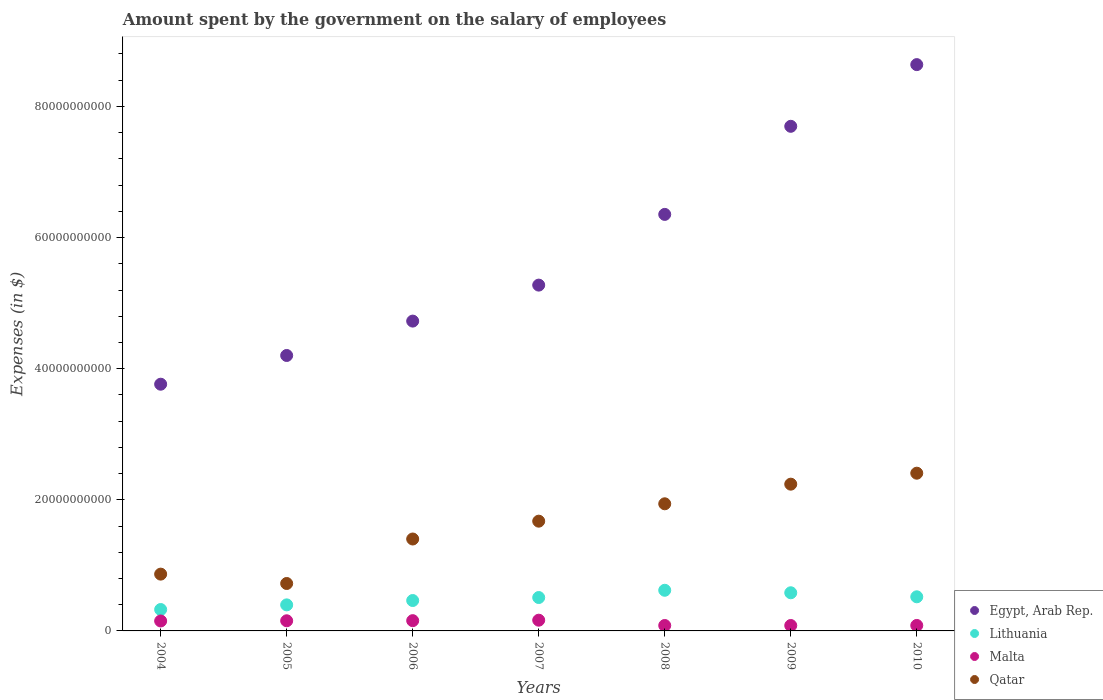How many different coloured dotlines are there?
Make the answer very short. 4. What is the amount spent on the salary of employees by the government in Qatar in 2008?
Your answer should be compact. 1.94e+1. Across all years, what is the maximum amount spent on the salary of employees by the government in Malta?
Your response must be concise. 1.64e+09. Across all years, what is the minimum amount spent on the salary of employees by the government in Malta?
Provide a short and direct response. 8.25e+08. In which year was the amount spent on the salary of employees by the government in Qatar minimum?
Keep it short and to the point. 2005. What is the total amount spent on the salary of employees by the government in Lithuania in the graph?
Keep it short and to the point. 3.42e+1. What is the difference between the amount spent on the salary of employees by the government in Malta in 2004 and that in 2006?
Your answer should be compact. -4.90e+07. What is the difference between the amount spent on the salary of employees by the government in Lithuania in 2009 and the amount spent on the salary of employees by the government in Qatar in 2010?
Make the answer very short. -1.82e+1. What is the average amount spent on the salary of employees by the government in Lithuania per year?
Your answer should be very brief. 4.88e+09. In the year 2006, what is the difference between the amount spent on the salary of employees by the government in Qatar and amount spent on the salary of employees by the government in Egypt, Arab Rep.?
Your answer should be very brief. -3.32e+1. In how many years, is the amount spent on the salary of employees by the government in Malta greater than 72000000000 $?
Ensure brevity in your answer.  0. What is the ratio of the amount spent on the salary of employees by the government in Malta in 2009 to that in 2010?
Make the answer very short. 0.99. Is the amount spent on the salary of employees by the government in Lithuania in 2004 less than that in 2008?
Keep it short and to the point. Yes. Is the difference between the amount spent on the salary of employees by the government in Qatar in 2008 and 2010 greater than the difference between the amount spent on the salary of employees by the government in Egypt, Arab Rep. in 2008 and 2010?
Your answer should be very brief. Yes. What is the difference between the highest and the second highest amount spent on the salary of employees by the government in Qatar?
Keep it short and to the point. 1.67e+09. What is the difference between the highest and the lowest amount spent on the salary of employees by the government in Egypt, Arab Rep.?
Offer a terse response. 4.87e+1. Is the sum of the amount spent on the salary of employees by the government in Lithuania in 2004 and 2006 greater than the maximum amount spent on the salary of employees by the government in Egypt, Arab Rep. across all years?
Give a very brief answer. No. Is it the case that in every year, the sum of the amount spent on the salary of employees by the government in Qatar and amount spent on the salary of employees by the government in Malta  is greater than the sum of amount spent on the salary of employees by the government in Egypt, Arab Rep. and amount spent on the salary of employees by the government in Lithuania?
Give a very brief answer. No. Is it the case that in every year, the sum of the amount spent on the salary of employees by the government in Qatar and amount spent on the salary of employees by the government in Lithuania  is greater than the amount spent on the salary of employees by the government in Malta?
Your answer should be very brief. Yes. Does the amount spent on the salary of employees by the government in Egypt, Arab Rep. monotonically increase over the years?
Provide a short and direct response. Yes. Does the graph contain grids?
Make the answer very short. No. How many legend labels are there?
Ensure brevity in your answer.  4. What is the title of the graph?
Your answer should be compact. Amount spent by the government on the salary of employees. What is the label or title of the Y-axis?
Provide a succinct answer. Expenses (in $). What is the Expenses (in $) in Egypt, Arab Rep. in 2004?
Provide a succinct answer. 3.76e+1. What is the Expenses (in $) in Lithuania in 2004?
Provide a short and direct response. 3.27e+09. What is the Expenses (in $) of Malta in 2004?
Your response must be concise. 1.52e+09. What is the Expenses (in $) in Qatar in 2004?
Offer a terse response. 8.66e+09. What is the Expenses (in $) of Egypt, Arab Rep. in 2005?
Your response must be concise. 4.20e+1. What is the Expenses (in $) in Lithuania in 2005?
Make the answer very short. 3.97e+09. What is the Expenses (in $) of Malta in 2005?
Offer a terse response. 1.55e+09. What is the Expenses (in $) in Qatar in 2005?
Make the answer very short. 7.23e+09. What is the Expenses (in $) in Egypt, Arab Rep. in 2006?
Provide a succinct answer. 4.73e+1. What is the Expenses (in $) in Lithuania in 2006?
Your answer should be very brief. 4.64e+09. What is the Expenses (in $) in Malta in 2006?
Your answer should be compact. 1.57e+09. What is the Expenses (in $) of Qatar in 2006?
Your answer should be compact. 1.40e+1. What is the Expenses (in $) in Egypt, Arab Rep. in 2007?
Provide a succinct answer. 5.27e+1. What is the Expenses (in $) in Lithuania in 2007?
Provide a succinct answer. 5.09e+09. What is the Expenses (in $) in Malta in 2007?
Ensure brevity in your answer.  1.64e+09. What is the Expenses (in $) in Qatar in 2007?
Make the answer very short. 1.67e+1. What is the Expenses (in $) in Egypt, Arab Rep. in 2008?
Provide a short and direct response. 6.35e+1. What is the Expenses (in $) of Lithuania in 2008?
Make the answer very short. 6.20e+09. What is the Expenses (in $) in Malta in 2008?
Provide a short and direct response. 8.27e+08. What is the Expenses (in $) of Qatar in 2008?
Your answer should be compact. 1.94e+1. What is the Expenses (in $) of Egypt, Arab Rep. in 2009?
Make the answer very short. 7.70e+1. What is the Expenses (in $) of Lithuania in 2009?
Make the answer very short. 5.82e+09. What is the Expenses (in $) in Malta in 2009?
Offer a terse response. 8.25e+08. What is the Expenses (in $) of Qatar in 2009?
Ensure brevity in your answer.  2.24e+1. What is the Expenses (in $) in Egypt, Arab Rep. in 2010?
Ensure brevity in your answer.  8.64e+1. What is the Expenses (in $) of Lithuania in 2010?
Give a very brief answer. 5.20e+09. What is the Expenses (in $) in Malta in 2010?
Ensure brevity in your answer.  8.35e+08. What is the Expenses (in $) in Qatar in 2010?
Your answer should be very brief. 2.41e+1. Across all years, what is the maximum Expenses (in $) in Egypt, Arab Rep.?
Provide a succinct answer. 8.64e+1. Across all years, what is the maximum Expenses (in $) of Lithuania?
Your answer should be very brief. 6.20e+09. Across all years, what is the maximum Expenses (in $) in Malta?
Make the answer very short. 1.64e+09. Across all years, what is the maximum Expenses (in $) in Qatar?
Provide a succinct answer. 2.41e+1. Across all years, what is the minimum Expenses (in $) of Egypt, Arab Rep.?
Your response must be concise. 3.76e+1. Across all years, what is the minimum Expenses (in $) of Lithuania?
Ensure brevity in your answer.  3.27e+09. Across all years, what is the minimum Expenses (in $) of Malta?
Keep it short and to the point. 8.25e+08. Across all years, what is the minimum Expenses (in $) in Qatar?
Give a very brief answer. 7.23e+09. What is the total Expenses (in $) in Egypt, Arab Rep. in the graph?
Ensure brevity in your answer.  4.07e+11. What is the total Expenses (in $) of Lithuania in the graph?
Provide a short and direct response. 3.42e+1. What is the total Expenses (in $) of Malta in the graph?
Your response must be concise. 8.75e+09. What is the total Expenses (in $) in Qatar in the graph?
Offer a very short reply. 1.12e+11. What is the difference between the Expenses (in $) in Egypt, Arab Rep. in 2004 and that in 2005?
Provide a succinct answer. -4.38e+09. What is the difference between the Expenses (in $) in Lithuania in 2004 and that in 2005?
Ensure brevity in your answer.  -7.08e+08. What is the difference between the Expenses (in $) in Malta in 2004 and that in 2005?
Offer a terse response. -3.07e+07. What is the difference between the Expenses (in $) in Qatar in 2004 and that in 2005?
Your answer should be compact. 1.43e+09. What is the difference between the Expenses (in $) of Egypt, Arab Rep. in 2004 and that in 2006?
Offer a very short reply. -9.63e+09. What is the difference between the Expenses (in $) in Lithuania in 2004 and that in 2006?
Make the answer very short. -1.37e+09. What is the difference between the Expenses (in $) in Malta in 2004 and that in 2006?
Ensure brevity in your answer.  -4.90e+07. What is the difference between the Expenses (in $) of Qatar in 2004 and that in 2006?
Make the answer very short. -5.36e+09. What is the difference between the Expenses (in $) of Egypt, Arab Rep. in 2004 and that in 2007?
Keep it short and to the point. -1.51e+1. What is the difference between the Expenses (in $) in Lithuania in 2004 and that in 2007?
Give a very brief answer. -1.83e+09. What is the difference between the Expenses (in $) in Malta in 2004 and that in 2007?
Give a very brief answer. -1.21e+08. What is the difference between the Expenses (in $) of Qatar in 2004 and that in 2007?
Offer a terse response. -8.08e+09. What is the difference between the Expenses (in $) of Egypt, Arab Rep. in 2004 and that in 2008?
Your answer should be compact. -2.59e+1. What is the difference between the Expenses (in $) of Lithuania in 2004 and that in 2008?
Your answer should be compact. -2.93e+09. What is the difference between the Expenses (in $) of Malta in 2004 and that in 2008?
Ensure brevity in your answer.  6.89e+08. What is the difference between the Expenses (in $) of Qatar in 2004 and that in 2008?
Offer a very short reply. -1.07e+1. What is the difference between the Expenses (in $) in Egypt, Arab Rep. in 2004 and that in 2009?
Offer a very short reply. -3.93e+1. What is the difference between the Expenses (in $) in Lithuania in 2004 and that in 2009?
Your answer should be very brief. -2.55e+09. What is the difference between the Expenses (in $) of Malta in 2004 and that in 2009?
Your answer should be very brief. 6.91e+08. What is the difference between the Expenses (in $) in Qatar in 2004 and that in 2009?
Give a very brief answer. -1.37e+1. What is the difference between the Expenses (in $) in Egypt, Arab Rep. in 2004 and that in 2010?
Your answer should be very brief. -4.87e+1. What is the difference between the Expenses (in $) of Lithuania in 2004 and that in 2010?
Provide a succinct answer. -1.94e+09. What is the difference between the Expenses (in $) of Malta in 2004 and that in 2010?
Ensure brevity in your answer.  6.81e+08. What is the difference between the Expenses (in $) in Qatar in 2004 and that in 2010?
Make the answer very short. -1.54e+1. What is the difference between the Expenses (in $) of Egypt, Arab Rep. in 2005 and that in 2006?
Your response must be concise. -5.25e+09. What is the difference between the Expenses (in $) in Lithuania in 2005 and that in 2006?
Offer a terse response. -6.63e+08. What is the difference between the Expenses (in $) in Malta in 2005 and that in 2006?
Give a very brief answer. -1.82e+07. What is the difference between the Expenses (in $) of Qatar in 2005 and that in 2006?
Make the answer very short. -6.79e+09. What is the difference between the Expenses (in $) of Egypt, Arab Rep. in 2005 and that in 2007?
Offer a very short reply. -1.07e+1. What is the difference between the Expenses (in $) of Lithuania in 2005 and that in 2007?
Provide a succinct answer. -1.12e+09. What is the difference between the Expenses (in $) of Malta in 2005 and that in 2007?
Offer a very short reply. -9.01e+07. What is the difference between the Expenses (in $) of Qatar in 2005 and that in 2007?
Ensure brevity in your answer.  -9.51e+09. What is the difference between the Expenses (in $) in Egypt, Arab Rep. in 2005 and that in 2008?
Provide a succinct answer. -2.15e+1. What is the difference between the Expenses (in $) in Lithuania in 2005 and that in 2008?
Make the answer very short. -2.23e+09. What is the difference between the Expenses (in $) in Malta in 2005 and that in 2008?
Your answer should be compact. 7.20e+08. What is the difference between the Expenses (in $) in Qatar in 2005 and that in 2008?
Provide a succinct answer. -1.22e+1. What is the difference between the Expenses (in $) of Egypt, Arab Rep. in 2005 and that in 2009?
Provide a short and direct response. -3.50e+1. What is the difference between the Expenses (in $) in Lithuania in 2005 and that in 2009?
Your answer should be compact. -1.85e+09. What is the difference between the Expenses (in $) of Malta in 2005 and that in 2009?
Offer a very short reply. 7.22e+08. What is the difference between the Expenses (in $) in Qatar in 2005 and that in 2009?
Make the answer very short. -1.52e+1. What is the difference between the Expenses (in $) of Egypt, Arab Rep. in 2005 and that in 2010?
Make the answer very short. -4.44e+1. What is the difference between the Expenses (in $) in Lithuania in 2005 and that in 2010?
Offer a terse response. -1.23e+09. What is the difference between the Expenses (in $) in Malta in 2005 and that in 2010?
Your answer should be compact. 7.12e+08. What is the difference between the Expenses (in $) in Qatar in 2005 and that in 2010?
Offer a terse response. -1.68e+1. What is the difference between the Expenses (in $) of Egypt, Arab Rep. in 2006 and that in 2007?
Provide a short and direct response. -5.49e+09. What is the difference between the Expenses (in $) of Lithuania in 2006 and that in 2007?
Give a very brief answer. -4.57e+08. What is the difference between the Expenses (in $) of Malta in 2006 and that in 2007?
Provide a short and direct response. -7.19e+07. What is the difference between the Expenses (in $) in Qatar in 2006 and that in 2007?
Provide a short and direct response. -2.72e+09. What is the difference between the Expenses (in $) in Egypt, Arab Rep. in 2006 and that in 2008?
Offer a terse response. -1.63e+1. What is the difference between the Expenses (in $) in Lithuania in 2006 and that in 2008?
Provide a short and direct response. -1.56e+09. What is the difference between the Expenses (in $) of Malta in 2006 and that in 2008?
Provide a short and direct response. 7.38e+08. What is the difference between the Expenses (in $) of Qatar in 2006 and that in 2008?
Your answer should be very brief. -5.37e+09. What is the difference between the Expenses (in $) of Egypt, Arab Rep. in 2006 and that in 2009?
Provide a short and direct response. -2.97e+1. What is the difference between the Expenses (in $) in Lithuania in 2006 and that in 2009?
Provide a succinct answer. -1.18e+09. What is the difference between the Expenses (in $) in Malta in 2006 and that in 2009?
Your response must be concise. 7.40e+08. What is the difference between the Expenses (in $) in Qatar in 2006 and that in 2009?
Your answer should be compact. -8.36e+09. What is the difference between the Expenses (in $) in Egypt, Arab Rep. in 2006 and that in 2010?
Your answer should be compact. -3.91e+1. What is the difference between the Expenses (in $) of Lithuania in 2006 and that in 2010?
Provide a succinct answer. -5.69e+08. What is the difference between the Expenses (in $) of Malta in 2006 and that in 2010?
Your answer should be very brief. 7.30e+08. What is the difference between the Expenses (in $) in Qatar in 2006 and that in 2010?
Your answer should be compact. -1.00e+1. What is the difference between the Expenses (in $) of Egypt, Arab Rep. in 2007 and that in 2008?
Your response must be concise. -1.08e+1. What is the difference between the Expenses (in $) of Lithuania in 2007 and that in 2008?
Provide a succinct answer. -1.11e+09. What is the difference between the Expenses (in $) in Malta in 2007 and that in 2008?
Offer a terse response. 8.10e+08. What is the difference between the Expenses (in $) of Qatar in 2007 and that in 2008?
Provide a succinct answer. -2.65e+09. What is the difference between the Expenses (in $) of Egypt, Arab Rep. in 2007 and that in 2009?
Your response must be concise. -2.42e+1. What is the difference between the Expenses (in $) in Lithuania in 2007 and that in 2009?
Your answer should be very brief. -7.26e+08. What is the difference between the Expenses (in $) of Malta in 2007 and that in 2009?
Make the answer very short. 8.12e+08. What is the difference between the Expenses (in $) in Qatar in 2007 and that in 2009?
Give a very brief answer. -5.64e+09. What is the difference between the Expenses (in $) of Egypt, Arab Rep. in 2007 and that in 2010?
Ensure brevity in your answer.  -3.36e+1. What is the difference between the Expenses (in $) in Lithuania in 2007 and that in 2010?
Keep it short and to the point. -1.11e+08. What is the difference between the Expenses (in $) of Malta in 2007 and that in 2010?
Keep it short and to the point. 8.02e+08. What is the difference between the Expenses (in $) in Qatar in 2007 and that in 2010?
Give a very brief answer. -7.32e+09. What is the difference between the Expenses (in $) in Egypt, Arab Rep. in 2008 and that in 2009?
Offer a terse response. -1.34e+1. What is the difference between the Expenses (in $) in Lithuania in 2008 and that in 2009?
Keep it short and to the point. 3.80e+08. What is the difference between the Expenses (in $) of Malta in 2008 and that in 2009?
Provide a succinct answer. 1.94e+06. What is the difference between the Expenses (in $) of Qatar in 2008 and that in 2009?
Your answer should be compact. -2.99e+09. What is the difference between the Expenses (in $) of Egypt, Arab Rep. in 2008 and that in 2010?
Provide a succinct answer. -2.28e+1. What is the difference between the Expenses (in $) of Lithuania in 2008 and that in 2010?
Your response must be concise. 9.94e+08. What is the difference between the Expenses (in $) of Malta in 2008 and that in 2010?
Provide a short and direct response. -7.42e+06. What is the difference between the Expenses (in $) in Qatar in 2008 and that in 2010?
Provide a short and direct response. -4.67e+09. What is the difference between the Expenses (in $) of Egypt, Arab Rep. in 2009 and that in 2010?
Offer a very short reply. -9.41e+09. What is the difference between the Expenses (in $) in Lithuania in 2009 and that in 2010?
Provide a short and direct response. 6.14e+08. What is the difference between the Expenses (in $) of Malta in 2009 and that in 2010?
Your answer should be very brief. -9.36e+06. What is the difference between the Expenses (in $) in Qatar in 2009 and that in 2010?
Ensure brevity in your answer.  -1.67e+09. What is the difference between the Expenses (in $) of Egypt, Arab Rep. in 2004 and the Expenses (in $) of Lithuania in 2005?
Your response must be concise. 3.37e+1. What is the difference between the Expenses (in $) of Egypt, Arab Rep. in 2004 and the Expenses (in $) of Malta in 2005?
Your answer should be very brief. 3.61e+1. What is the difference between the Expenses (in $) in Egypt, Arab Rep. in 2004 and the Expenses (in $) in Qatar in 2005?
Offer a very short reply. 3.04e+1. What is the difference between the Expenses (in $) of Lithuania in 2004 and the Expenses (in $) of Malta in 2005?
Offer a terse response. 1.72e+09. What is the difference between the Expenses (in $) in Lithuania in 2004 and the Expenses (in $) in Qatar in 2005?
Provide a short and direct response. -3.97e+09. What is the difference between the Expenses (in $) of Malta in 2004 and the Expenses (in $) of Qatar in 2005?
Provide a succinct answer. -5.72e+09. What is the difference between the Expenses (in $) of Egypt, Arab Rep. in 2004 and the Expenses (in $) of Lithuania in 2006?
Ensure brevity in your answer.  3.30e+1. What is the difference between the Expenses (in $) of Egypt, Arab Rep. in 2004 and the Expenses (in $) of Malta in 2006?
Your response must be concise. 3.61e+1. What is the difference between the Expenses (in $) of Egypt, Arab Rep. in 2004 and the Expenses (in $) of Qatar in 2006?
Keep it short and to the point. 2.36e+1. What is the difference between the Expenses (in $) of Lithuania in 2004 and the Expenses (in $) of Malta in 2006?
Provide a succinct answer. 1.70e+09. What is the difference between the Expenses (in $) in Lithuania in 2004 and the Expenses (in $) in Qatar in 2006?
Provide a short and direct response. -1.08e+1. What is the difference between the Expenses (in $) of Malta in 2004 and the Expenses (in $) of Qatar in 2006?
Your response must be concise. -1.25e+1. What is the difference between the Expenses (in $) of Egypt, Arab Rep. in 2004 and the Expenses (in $) of Lithuania in 2007?
Provide a succinct answer. 3.25e+1. What is the difference between the Expenses (in $) in Egypt, Arab Rep. in 2004 and the Expenses (in $) in Malta in 2007?
Your answer should be compact. 3.60e+1. What is the difference between the Expenses (in $) in Egypt, Arab Rep. in 2004 and the Expenses (in $) in Qatar in 2007?
Offer a very short reply. 2.09e+1. What is the difference between the Expenses (in $) of Lithuania in 2004 and the Expenses (in $) of Malta in 2007?
Your response must be concise. 1.63e+09. What is the difference between the Expenses (in $) in Lithuania in 2004 and the Expenses (in $) in Qatar in 2007?
Provide a succinct answer. -1.35e+1. What is the difference between the Expenses (in $) of Malta in 2004 and the Expenses (in $) of Qatar in 2007?
Keep it short and to the point. -1.52e+1. What is the difference between the Expenses (in $) of Egypt, Arab Rep. in 2004 and the Expenses (in $) of Lithuania in 2008?
Offer a terse response. 3.14e+1. What is the difference between the Expenses (in $) in Egypt, Arab Rep. in 2004 and the Expenses (in $) in Malta in 2008?
Give a very brief answer. 3.68e+1. What is the difference between the Expenses (in $) of Egypt, Arab Rep. in 2004 and the Expenses (in $) of Qatar in 2008?
Your response must be concise. 1.82e+1. What is the difference between the Expenses (in $) of Lithuania in 2004 and the Expenses (in $) of Malta in 2008?
Your response must be concise. 2.44e+09. What is the difference between the Expenses (in $) of Lithuania in 2004 and the Expenses (in $) of Qatar in 2008?
Offer a terse response. -1.61e+1. What is the difference between the Expenses (in $) of Malta in 2004 and the Expenses (in $) of Qatar in 2008?
Offer a terse response. -1.79e+1. What is the difference between the Expenses (in $) of Egypt, Arab Rep. in 2004 and the Expenses (in $) of Lithuania in 2009?
Your answer should be compact. 3.18e+1. What is the difference between the Expenses (in $) in Egypt, Arab Rep. in 2004 and the Expenses (in $) in Malta in 2009?
Provide a short and direct response. 3.68e+1. What is the difference between the Expenses (in $) of Egypt, Arab Rep. in 2004 and the Expenses (in $) of Qatar in 2009?
Provide a short and direct response. 1.52e+1. What is the difference between the Expenses (in $) in Lithuania in 2004 and the Expenses (in $) in Malta in 2009?
Provide a short and direct response. 2.44e+09. What is the difference between the Expenses (in $) in Lithuania in 2004 and the Expenses (in $) in Qatar in 2009?
Make the answer very short. -1.91e+1. What is the difference between the Expenses (in $) in Malta in 2004 and the Expenses (in $) in Qatar in 2009?
Ensure brevity in your answer.  -2.09e+1. What is the difference between the Expenses (in $) of Egypt, Arab Rep. in 2004 and the Expenses (in $) of Lithuania in 2010?
Keep it short and to the point. 3.24e+1. What is the difference between the Expenses (in $) in Egypt, Arab Rep. in 2004 and the Expenses (in $) in Malta in 2010?
Keep it short and to the point. 3.68e+1. What is the difference between the Expenses (in $) in Egypt, Arab Rep. in 2004 and the Expenses (in $) in Qatar in 2010?
Make the answer very short. 1.36e+1. What is the difference between the Expenses (in $) of Lithuania in 2004 and the Expenses (in $) of Malta in 2010?
Give a very brief answer. 2.43e+09. What is the difference between the Expenses (in $) of Lithuania in 2004 and the Expenses (in $) of Qatar in 2010?
Keep it short and to the point. -2.08e+1. What is the difference between the Expenses (in $) of Malta in 2004 and the Expenses (in $) of Qatar in 2010?
Your answer should be very brief. -2.25e+1. What is the difference between the Expenses (in $) of Egypt, Arab Rep. in 2005 and the Expenses (in $) of Lithuania in 2006?
Your answer should be very brief. 3.74e+1. What is the difference between the Expenses (in $) in Egypt, Arab Rep. in 2005 and the Expenses (in $) in Malta in 2006?
Offer a terse response. 4.04e+1. What is the difference between the Expenses (in $) in Egypt, Arab Rep. in 2005 and the Expenses (in $) in Qatar in 2006?
Your response must be concise. 2.80e+1. What is the difference between the Expenses (in $) of Lithuania in 2005 and the Expenses (in $) of Malta in 2006?
Offer a terse response. 2.41e+09. What is the difference between the Expenses (in $) of Lithuania in 2005 and the Expenses (in $) of Qatar in 2006?
Give a very brief answer. -1.00e+1. What is the difference between the Expenses (in $) of Malta in 2005 and the Expenses (in $) of Qatar in 2006?
Offer a terse response. -1.25e+1. What is the difference between the Expenses (in $) of Egypt, Arab Rep. in 2005 and the Expenses (in $) of Lithuania in 2007?
Give a very brief answer. 3.69e+1. What is the difference between the Expenses (in $) of Egypt, Arab Rep. in 2005 and the Expenses (in $) of Malta in 2007?
Ensure brevity in your answer.  4.04e+1. What is the difference between the Expenses (in $) in Egypt, Arab Rep. in 2005 and the Expenses (in $) in Qatar in 2007?
Ensure brevity in your answer.  2.53e+1. What is the difference between the Expenses (in $) in Lithuania in 2005 and the Expenses (in $) in Malta in 2007?
Your response must be concise. 2.34e+09. What is the difference between the Expenses (in $) of Lithuania in 2005 and the Expenses (in $) of Qatar in 2007?
Offer a very short reply. -1.28e+1. What is the difference between the Expenses (in $) of Malta in 2005 and the Expenses (in $) of Qatar in 2007?
Offer a terse response. -1.52e+1. What is the difference between the Expenses (in $) in Egypt, Arab Rep. in 2005 and the Expenses (in $) in Lithuania in 2008?
Your answer should be very brief. 3.58e+1. What is the difference between the Expenses (in $) of Egypt, Arab Rep. in 2005 and the Expenses (in $) of Malta in 2008?
Your answer should be very brief. 4.12e+1. What is the difference between the Expenses (in $) in Egypt, Arab Rep. in 2005 and the Expenses (in $) in Qatar in 2008?
Ensure brevity in your answer.  2.26e+1. What is the difference between the Expenses (in $) of Lithuania in 2005 and the Expenses (in $) of Malta in 2008?
Your answer should be very brief. 3.15e+09. What is the difference between the Expenses (in $) in Lithuania in 2005 and the Expenses (in $) in Qatar in 2008?
Give a very brief answer. -1.54e+1. What is the difference between the Expenses (in $) in Malta in 2005 and the Expenses (in $) in Qatar in 2008?
Your response must be concise. -1.78e+1. What is the difference between the Expenses (in $) in Egypt, Arab Rep. in 2005 and the Expenses (in $) in Lithuania in 2009?
Offer a very short reply. 3.62e+1. What is the difference between the Expenses (in $) of Egypt, Arab Rep. in 2005 and the Expenses (in $) of Malta in 2009?
Offer a very short reply. 4.12e+1. What is the difference between the Expenses (in $) of Egypt, Arab Rep. in 2005 and the Expenses (in $) of Qatar in 2009?
Give a very brief answer. 1.96e+1. What is the difference between the Expenses (in $) in Lithuania in 2005 and the Expenses (in $) in Malta in 2009?
Keep it short and to the point. 3.15e+09. What is the difference between the Expenses (in $) of Lithuania in 2005 and the Expenses (in $) of Qatar in 2009?
Give a very brief answer. -1.84e+1. What is the difference between the Expenses (in $) of Malta in 2005 and the Expenses (in $) of Qatar in 2009?
Provide a short and direct response. -2.08e+1. What is the difference between the Expenses (in $) in Egypt, Arab Rep. in 2005 and the Expenses (in $) in Lithuania in 2010?
Your response must be concise. 3.68e+1. What is the difference between the Expenses (in $) in Egypt, Arab Rep. in 2005 and the Expenses (in $) in Malta in 2010?
Your response must be concise. 4.12e+1. What is the difference between the Expenses (in $) in Egypt, Arab Rep. in 2005 and the Expenses (in $) in Qatar in 2010?
Your response must be concise. 1.80e+1. What is the difference between the Expenses (in $) of Lithuania in 2005 and the Expenses (in $) of Malta in 2010?
Give a very brief answer. 3.14e+09. What is the difference between the Expenses (in $) of Lithuania in 2005 and the Expenses (in $) of Qatar in 2010?
Your answer should be compact. -2.01e+1. What is the difference between the Expenses (in $) of Malta in 2005 and the Expenses (in $) of Qatar in 2010?
Your response must be concise. -2.25e+1. What is the difference between the Expenses (in $) in Egypt, Arab Rep. in 2006 and the Expenses (in $) in Lithuania in 2007?
Your answer should be compact. 4.22e+1. What is the difference between the Expenses (in $) of Egypt, Arab Rep. in 2006 and the Expenses (in $) of Malta in 2007?
Ensure brevity in your answer.  4.56e+1. What is the difference between the Expenses (in $) of Egypt, Arab Rep. in 2006 and the Expenses (in $) of Qatar in 2007?
Ensure brevity in your answer.  3.05e+1. What is the difference between the Expenses (in $) of Lithuania in 2006 and the Expenses (in $) of Malta in 2007?
Offer a very short reply. 3.00e+09. What is the difference between the Expenses (in $) in Lithuania in 2006 and the Expenses (in $) in Qatar in 2007?
Offer a terse response. -1.21e+1. What is the difference between the Expenses (in $) in Malta in 2006 and the Expenses (in $) in Qatar in 2007?
Your response must be concise. -1.52e+1. What is the difference between the Expenses (in $) in Egypt, Arab Rep. in 2006 and the Expenses (in $) in Lithuania in 2008?
Your answer should be compact. 4.11e+1. What is the difference between the Expenses (in $) of Egypt, Arab Rep. in 2006 and the Expenses (in $) of Malta in 2008?
Keep it short and to the point. 4.64e+1. What is the difference between the Expenses (in $) of Egypt, Arab Rep. in 2006 and the Expenses (in $) of Qatar in 2008?
Give a very brief answer. 2.79e+1. What is the difference between the Expenses (in $) in Lithuania in 2006 and the Expenses (in $) in Malta in 2008?
Keep it short and to the point. 3.81e+09. What is the difference between the Expenses (in $) of Lithuania in 2006 and the Expenses (in $) of Qatar in 2008?
Ensure brevity in your answer.  -1.48e+1. What is the difference between the Expenses (in $) of Malta in 2006 and the Expenses (in $) of Qatar in 2008?
Give a very brief answer. -1.78e+1. What is the difference between the Expenses (in $) of Egypt, Arab Rep. in 2006 and the Expenses (in $) of Lithuania in 2009?
Provide a succinct answer. 4.14e+1. What is the difference between the Expenses (in $) in Egypt, Arab Rep. in 2006 and the Expenses (in $) in Malta in 2009?
Offer a terse response. 4.64e+1. What is the difference between the Expenses (in $) in Egypt, Arab Rep. in 2006 and the Expenses (in $) in Qatar in 2009?
Offer a terse response. 2.49e+1. What is the difference between the Expenses (in $) in Lithuania in 2006 and the Expenses (in $) in Malta in 2009?
Your answer should be very brief. 3.81e+09. What is the difference between the Expenses (in $) of Lithuania in 2006 and the Expenses (in $) of Qatar in 2009?
Your answer should be very brief. -1.77e+1. What is the difference between the Expenses (in $) of Malta in 2006 and the Expenses (in $) of Qatar in 2009?
Offer a very short reply. -2.08e+1. What is the difference between the Expenses (in $) in Egypt, Arab Rep. in 2006 and the Expenses (in $) in Lithuania in 2010?
Keep it short and to the point. 4.21e+1. What is the difference between the Expenses (in $) in Egypt, Arab Rep. in 2006 and the Expenses (in $) in Malta in 2010?
Make the answer very short. 4.64e+1. What is the difference between the Expenses (in $) of Egypt, Arab Rep. in 2006 and the Expenses (in $) of Qatar in 2010?
Give a very brief answer. 2.32e+1. What is the difference between the Expenses (in $) of Lithuania in 2006 and the Expenses (in $) of Malta in 2010?
Offer a terse response. 3.80e+09. What is the difference between the Expenses (in $) in Lithuania in 2006 and the Expenses (in $) in Qatar in 2010?
Ensure brevity in your answer.  -1.94e+1. What is the difference between the Expenses (in $) of Malta in 2006 and the Expenses (in $) of Qatar in 2010?
Your answer should be very brief. -2.25e+1. What is the difference between the Expenses (in $) of Egypt, Arab Rep. in 2007 and the Expenses (in $) of Lithuania in 2008?
Offer a terse response. 4.65e+1. What is the difference between the Expenses (in $) of Egypt, Arab Rep. in 2007 and the Expenses (in $) of Malta in 2008?
Your response must be concise. 5.19e+1. What is the difference between the Expenses (in $) in Egypt, Arab Rep. in 2007 and the Expenses (in $) in Qatar in 2008?
Your response must be concise. 3.34e+1. What is the difference between the Expenses (in $) of Lithuania in 2007 and the Expenses (in $) of Malta in 2008?
Keep it short and to the point. 4.27e+09. What is the difference between the Expenses (in $) of Lithuania in 2007 and the Expenses (in $) of Qatar in 2008?
Offer a terse response. -1.43e+1. What is the difference between the Expenses (in $) of Malta in 2007 and the Expenses (in $) of Qatar in 2008?
Ensure brevity in your answer.  -1.78e+1. What is the difference between the Expenses (in $) of Egypt, Arab Rep. in 2007 and the Expenses (in $) of Lithuania in 2009?
Make the answer very short. 4.69e+1. What is the difference between the Expenses (in $) of Egypt, Arab Rep. in 2007 and the Expenses (in $) of Malta in 2009?
Provide a short and direct response. 5.19e+1. What is the difference between the Expenses (in $) in Egypt, Arab Rep. in 2007 and the Expenses (in $) in Qatar in 2009?
Ensure brevity in your answer.  3.04e+1. What is the difference between the Expenses (in $) in Lithuania in 2007 and the Expenses (in $) in Malta in 2009?
Make the answer very short. 4.27e+09. What is the difference between the Expenses (in $) in Lithuania in 2007 and the Expenses (in $) in Qatar in 2009?
Your response must be concise. -1.73e+1. What is the difference between the Expenses (in $) in Malta in 2007 and the Expenses (in $) in Qatar in 2009?
Your answer should be compact. -2.07e+1. What is the difference between the Expenses (in $) in Egypt, Arab Rep. in 2007 and the Expenses (in $) in Lithuania in 2010?
Provide a short and direct response. 4.75e+1. What is the difference between the Expenses (in $) of Egypt, Arab Rep. in 2007 and the Expenses (in $) of Malta in 2010?
Give a very brief answer. 5.19e+1. What is the difference between the Expenses (in $) in Egypt, Arab Rep. in 2007 and the Expenses (in $) in Qatar in 2010?
Your answer should be compact. 2.87e+1. What is the difference between the Expenses (in $) of Lithuania in 2007 and the Expenses (in $) of Malta in 2010?
Keep it short and to the point. 4.26e+09. What is the difference between the Expenses (in $) in Lithuania in 2007 and the Expenses (in $) in Qatar in 2010?
Your answer should be compact. -1.90e+1. What is the difference between the Expenses (in $) in Malta in 2007 and the Expenses (in $) in Qatar in 2010?
Provide a short and direct response. -2.24e+1. What is the difference between the Expenses (in $) of Egypt, Arab Rep. in 2008 and the Expenses (in $) of Lithuania in 2009?
Provide a succinct answer. 5.77e+1. What is the difference between the Expenses (in $) in Egypt, Arab Rep. in 2008 and the Expenses (in $) in Malta in 2009?
Provide a succinct answer. 6.27e+1. What is the difference between the Expenses (in $) in Egypt, Arab Rep. in 2008 and the Expenses (in $) in Qatar in 2009?
Offer a terse response. 4.11e+1. What is the difference between the Expenses (in $) in Lithuania in 2008 and the Expenses (in $) in Malta in 2009?
Provide a succinct answer. 5.37e+09. What is the difference between the Expenses (in $) in Lithuania in 2008 and the Expenses (in $) in Qatar in 2009?
Offer a very short reply. -1.62e+1. What is the difference between the Expenses (in $) in Malta in 2008 and the Expenses (in $) in Qatar in 2009?
Offer a very short reply. -2.16e+1. What is the difference between the Expenses (in $) of Egypt, Arab Rep. in 2008 and the Expenses (in $) of Lithuania in 2010?
Give a very brief answer. 5.83e+1. What is the difference between the Expenses (in $) of Egypt, Arab Rep. in 2008 and the Expenses (in $) of Malta in 2010?
Offer a terse response. 6.27e+1. What is the difference between the Expenses (in $) of Egypt, Arab Rep. in 2008 and the Expenses (in $) of Qatar in 2010?
Ensure brevity in your answer.  3.95e+1. What is the difference between the Expenses (in $) in Lithuania in 2008 and the Expenses (in $) in Malta in 2010?
Provide a short and direct response. 5.36e+09. What is the difference between the Expenses (in $) in Lithuania in 2008 and the Expenses (in $) in Qatar in 2010?
Provide a succinct answer. -1.79e+1. What is the difference between the Expenses (in $) in Malta in 2008 and the Expenses (in $) in Qatar in 2010?
Keep it short and to the point. -2.32e+1. What is the difference between the Expenses (in $) of Egypt, Arab Rep. in 2009 and the Expenses (in $) of Lithuania in 2010?
Ensure brevity in your answer.  7.18e+1. What is the difference between the Expenses (in $) of Egypt, Arab Rep. in 2009 and the Expenses (in $) of Malta in 2010?
Offer a very short reply. 7.61e+1. What is the difference between the Expenses (in $) of Egypt, Arab Rep. in 2009 and the Expenses (in $) of Qatar in 2010?
Provide a short and direct response. 5.29e+1. What is the difference between the Expenses (in $) of Lithuania in 2009 and the Expenses (in $) of Malta in 2010?
Provide a succinct answer. 4.98e+09. What is the difference between the Expenses (in $) in Lithuania in 2009 and the Expenses (in $) in Qatar in 2010?
Keep it short and to the point. -1.82e+1. What is the difference between the Expenses (in $) of Malta in 2009 and the Expenses (in $) of Qatar in 2010?
Make the answer very short. -2.32e+1. What is the average Expenses (in $) in Egypt, Arab Rep. per year?
Your answer should be compact. 5.81e+1. What is the average Expenses (in $) in Lithuania per year?
Offer a very short reply. 4.88e+09. What is the average Expenses (in $) of Malta per year?
Your answer should be very brief. 1.25e+09. What is the average Expenses (in $) of Qatar per year?
Make the answer very short. 1.61e+1. In the year 2004, what is the difference between the Expenses (in $) in Egypt, Arab Rep. and Expenses (in $) in Lithuania?
Offer a very short reply. 3.44e+1. In the year 2004, what is the difference between the Expenses (in $) in Egypt, Arab Rep. and Expenses (in $) in Malta?
Give a very brief answer. 3.61e+1. In the year 2004, what is the difference between the Expenses (in $) in Egypt, Arab Rep. and Expenses (in $) in Qatar?
Give a very brief answer. 2.90e+1. In the year 2004, what is the difference between the Expenses (in $) in Lithuania and Expenses (in $) in Malta?
Give a very brief answer. 1.75e+09. In the year 2004, what is the difference between the Expenses (in $) in Lithuania and Expenses (in $) in Qatar?
Your answer should be compact. -5.40e+09. In the year 2004, what is the difference between the Expenses (in $) in Malta and Expenses (in $) in Qatar?
Provide a succinct answer. -7.15e+09. In the year 2005, what is the difference between the Expenses (in $) in Egypt, Arab Rep. and Expenses (in $) in Lithuania?
Keep it short and to the point. 3.80e+1. In the year 2005, what is the difference between the Expenses (in $) in Egypt, Arab Rep. and Expenses (in $) in Malta?
Provide a succinct answer. 4.05e+1. In the year 2005, what is the difference between the Expenses (in $) in Egypt, Arab Rep. and Expenses (in $) in Qatar?
Give a very brief answer. 3.48e+1. In the year 2005, what is the difference between the Expenses (in $) in Lithuania and Expenses (in $) in Malta?
Ensure brevity in your answer.  2.43e+09. In the year 2005, what is the difference between the Expenses (in $) in Lithuania and Expenses (in $) in Qatar?
Your response must be concise. -3.26e+09. In the year 2005, what is the difference between the Expenses (in $) in Malta and Expenses (in $) in Qatar?
Provide a short and direct response. -5.69e+09. In the year 2006, what is the difference between the Expenses (in $) of Egypt, Arab Rep. and Expenses (in $) of Lithuania?
Offer a very short reply. 4.26e+1. In the year 2006, what is the difference between the Expenses (in $) of Egypt, Arab Rep. and Expenses (in $) of Malta?
Offer a terse response. 4.57e+1. In the year 2006, what is the difference between the Expenses (in $) of Egypt, Arab Rep. and Expenses (in $) of Qatar?
Keep it short and to the point. 3.32e+1. In the year 2006, what is the difference between the Expenses (in $) of Lithuania and Expenses (in $) of Malta?
Ensure brevity in your answer.  3.07e+09. In the year 2006, what is the difference between the Expenses (in $) of Lithuania and Expenses (in $) of Qatar?
Give a very brief answer. -9.38e+09. In the year 2006, what is the difference between the Expenses (in $) of Malta and Expenses (in $) of Qatar?
Provide a short and direct response. -1.25e+1. In the year 2007, what is the difference between the Expenses (in $) of Egypt, Arab Rep. and Expenses (in $) of Lithuania?
Provide a short and direct response. 4.77e+1. In the year 2007, what is the difference between the Expenses (in $) in Egypt, Arab Rep. and Expenses (in $) in Malta?
Give a very brief answer. 5.11e+1. In the year 2007, what is the difference between the Expenses (in $) of Egypt, Arab Rep. and Expenses (in $) of Qatar?
Your answer should be compact. 3.60e+1. In the year 2007, what is the difference between the Expenses (in $) of Lithuania and Expenses (in $) of Malta?
Your response must be concise. 3.46e+09. In the year 2007, what is the difference between the Expenses (in $) of Lithuania and Expenses (in $) of Qatar?
Your response must be concise. -1.16e+1. In the year 2007, what is the difference between the Expenses (in $) of Malta and Expenses (in $) of Qatar?
Your answer should be very brief. -1.51e+1. In the year 2008, what is the difference between the Expenses (in $) in Egypt, Arab Rep. and Expenses (in $) in Lithuania?
Your response must be concise. 5.73e+1. In the year 2008, what is the difference between the Expenses (in $) in Egypt, Arab Rep. and Expenses (in $) in Malta?
Make the answer very short. 6.27e+1. In the year 2008, what is the difference between the Expenses (in $) of Egypt, Arab Rep. and Expenses (in $) of Qatar?
Offer a terse response. 4.41e+1. In the year 2008, what is the difference between the Expenses (in $) in Lithuania and Expenses (in $) in Malta?
Provide a short and direct response. 5.37e+09. In the year 2008, what is the difference between the Expenses (in $) of Lithuania and Expenses (in $) of Qatar?
Your response must be concise. -1.32e+1. In the year 2008, what is the difference between the Expenses (in $) of Malta and Expenses (in $) of Qatar?
Make the answer very short. -1.86e+1. In the year 2009, what is the difference between the Expenses (in $) of Egypt, Arab Rep. and Expenses (in $) of Lithuania?
Give a very brief answer. 7.11e+1. In the year 2009, what is the difference between the Expenses (in $) in Egypt, Arab Rep. and Expenses (in $) in Malta?
Give a very brief answer. 7.61e+1. In the year 2009, what is the difference between the Expenses (in $) in Egypt, Arab Rep. and Expenses (in $) in Qatar?
Your answer should be compact. 5.46e+1. In the year 2009, what is the difference between the Expenses (in $) of Lithuania and Expenses (in $) of Malta?
Provide a short and direct response. 4.99e+09. In the year 2009, what is the difference between the Expenses (in $) of Lithuania and Expenses (in $) of Qatar?
Your answer should be very brief. -1.66e+1. In the year 2009, what is the difference between the Expenses (in $) of Malta and Expenses (in $) of Qatar?
Make the answer very short. -2.16e+1. In the year 2010, what is the difference between the Expenses (in $) of Egypt, Arab Rep. and Expenses (in $) of Lithuania?
Your answer should be very brief. 8.12e+1. In the year 2010, what is the difference between the Expenses (in $) of Egypt, Arab Rep. and Expenses (in $) of Malta?
Provide a succinct answer. 8.55e+1. In the year 2010, what is the difference between the Expenses (in $) in Egypt, Arab Rep. and Expenses (in $) in Qatar?
Your answer should be very brief. 6.23e+1. In the year 2010, what is the difference between the Expenses (in $) of Lithuania and Expenses (in $) of Malta?
Provide a short and direct response. 4.37e+09. In the year 2010, what is the difference between the Expenses (in $) in Lithuania and Expenses (in $) in Qatar?
Offer a very short reply. -1.89e+1. In the year 2010, what is the difference between the Expenses (in $) in Malta and Expenses (in $) in Qatar?
Provide a short and direct response. -2.32e+1. What is the ratio of the Expenses (in $) in Egypt, Arab Rep. in 2004 to that in 2005?
Offer a very short reply. 0.9. What is the ratio of the Expenses (in $) in Lithuania in 2004 to that in 2005?
Offer a terse response. 0.82. What is the ratio of the Expenses (in $) in Malta in 2004 to that in 2005?
Offer a terse response. 0.98. What is the ratio of the Expenses (in $) in Qatar in 2004 to that in 2005?
Give a very brief answer. 1.2. What is the ratio of the Expenses (in $) in Egypt, Arab Rep. in 2004 to that in 2006?
Ensure brevity in your answer.  0.8. What is the ratio of the Expenses (in $) of Lithuania in 2004 to that in 2006?
Make the answer very short. 0.7. What is the ratio of the Expenses (in $) of Malta in 2004 to that in 2006?
Offer a terse response. 0.97. What is the ratio of the Expenses (in $) of Qatar in 2004 to that in 2006?
Provide a short and direct response. 0.62. What is the ratio of the Expenses (in $) of Egypt, Arab Rep. in 2004 to that in 2007?
Offer a very short reply. 0.71. What is the ratio of the Expenses (in $) in Lithuania in 2004 to that in 2007?
Ensure brevity in your answer.  0.64. What is the ratio of the Expenses (in $) in Malta in 2004 to that in 2007?
Make the answer very short. 0.93. What is the ratio of the Expenses (in $) of Qatar in 2004 to that in 2007?
Provide a succinct answer. 0.52. What is the ratio of the Expenses (in $) of Egypt, Arab Rep. in 2004 to that in 2008?
Make the answer very short. 0.59. What is the ratio of the Expenses (in $) of Lithuania in 2004 to that in 2008?
Offer a terse response. 0.53. What is the ratio of the Expenses (in $) of Malta in 2004 to that in 2008?
Offer a terse response. 1.83. What is the ratio of the Expenses (in $) of Qatar in 2004 to that in 2008?
Your response must be concise. 0.45. What is the ratio of the Expenses (in $) in Egypt, Arab Rep. in 2004 to that in 2009?
Give a very brief answer. 0.49. What is the ratio of the Expenses (in $) of Lithuania in 2004 to that in 2009?
Make the answer very short. 0.56. What is the ratio of the Expenses (in $) of Malta in 2004 to that in 2009?
Offer a terse response. 1.84. What is the ratio of the Expenses (in $) of Qatar in 2004 to that in 2009?
Provide a short and direct response. 0.39. What is the ratio of the Expenses (in $) of Egypt, Arab Rep. in 2004 to that in 2010?
Offer a terse response. 0.44. What is the ratio of the Expenses (in $) in Lithuania in 2004 to that in 2010?
Provide a succinct answer. 0.63. What is the ratio of the Expenses (in $) in Malta in 2004 to that in 2010?
Provide a short and direct response. 1.82. What is the ratio of the Expenses (in $) of Qatar in 2004 to that in 2010?
Provide a succinct answer. 0.36. What is the ratio of the Expenses (in $) of Egypt, Arab Rep. in 2005 to that in 2006?
Give a very brief answer. 0.89. What is the ratio of the Expenses (in $) of Lithuania in 2005 to that in 2006?
Your answer should be compact. 0.86. What is the ratio of the Expenses (in $) of Malta in 2005 to that in 2006?
Your response must be concise. 0.99. What is the ratio of the Expenses (in $) in Qatar in 2005 to that in 2006?
Your answer should be compact. 0.52. What is the ratio of the Expenses (in $) of Egypt, Arab Rep. in 2005 to that in 2007?
Your answer should be very brief. 0.8. What is the ratio of the Expenses (in $) of Lithuania in 2005 to that in 2007?
Keep it short and to the point. 0.78. What is the ratio of the Expenses (in $) in Malta in 2005 to that in 2007?
Your response must be concise. 0.94. What is the ratio of the Expenses (in $) of Qatar in 2005 to that in 2007?
Your answer should be very brief. 0.43. What is the ratio of the Expenses (in $) of Egypt, Arab Rep. in 2005 to that in 2008?
Give a very brief answer. 0.66. What is the ratio of the Expenses (in $) of Lithuania in 2005 to that in 2008?
Provide a short and direct response. 0.64. What is the ratio of the Expenses (in $) in Malta in 2005 to that in 2008?
Provide a succinct answer. 1.87. What is the ratio of the Expenses (in $) in Qatar in 2005 to that in 2008?
Offer a terse response. 0.37. What is the ratio of the Expenses (in $) of Egypt, Arab Rep. in 2005 to that in 2009?
Keep it short and to the point. 0.55. What is the ratio of the Expenses (in $) of Lithuania in 2005 to that in 2009?
Provide a short and direct response. 0.68. What is the ratio of the Expenses (in $) in Malta in 2005 to that in 2009?
Offer a terse response. 1.87. What is the ratio of the Expenses (in $) of Qatar in 2005 to that in 2009?
Give a very brief answer. 0.32. What is the ratio of the Expenses (in $) in Egypt, Arab Rep. in 2005 to that in 2010?
Offer a terse response. 0.49. What is the ratio of the Expenses (in $) of Lithuania in 2005 to that in 2010?
Your answer should be compact. 0.76. What is the ratio of the Expenses (in $) in Malta in 2005 to that in 2010?
Offer a terse response. 1.85. What is the ratio of the Expenses (in $) of Qatar in 2005 to that in 2010?
Make the answer very short. 0.3. What is the ratio of the Expenses (in $) in Egypt, Arab Rep. in 2006 to that in 2007?
Offer a very short reply. 0.9. What is the ratio of the Expenses (in $) in Lithuania in 2006 to that in 2007?
Your answer should be very brief. 0.91. What is the ratio of the Expenses (in $) in Malta in 2006 to that in 2007?
Offer a terse response. 0.96. What is the ratio of the Expenses (in $) in Qatar in 2006 to that in 2007?
Offer a terse response. 0.84. What is the ratio of the Expenses (in $) in Egypt, Arab Rep. in 2006 to that in 2008?
Provide a succinct answer. 0.74. What is the ratio of the Expenses (in $) of Lithuania in 2006 to that in 2008?
Keep it short and to the point. 0.75. What is the ratio of the Expenses (in $) in Malta in 2006 to that in 2008?
Offer a terse response. 1.89. What is the ratio of the Expenses (in $) in Qatar in 2006 to that in 2008?
Make the answer very short. 0.72. What is the ratio of the Expenses (in $) of Egypt, Arab Rep. in 2006 to that in 2009?
Your answer should be very brief. 0.61. What is the ratio of the Expenses (in $) in Lithuania in 2006 to that in 2009?
Provide a short and direct response. 0.8. What is the ratio of the Expenses (in $) in Malta in 2006 to that in 2009?
Keep it short and to the point. 1.9. What is the ratio of the Expenses (in $) in Qatar in 2006 to that in 2009?
Your answer should be very brief. 0.63. What is the ratio of the Expenses (in $) in Egypt, Arab Rep. in 2006 to that in 2010?
Offer a terse response. 0.55. What is the ratio of the Expenses (in $) of Lithuania in 2006 to that in 2010?
Offer a terse response. 0.89. What is the ratio of the Expenses (in $) of Malta in 2006 to that in 2010?
Keep it short and to the point. 1.88. What is the ratio of the Expenses (in $) in Qatar in 2006 to that in 2010?
Provide a succinct answer. 0.58. What is the ratio of the Expenses (in $) in Egypt, Arab Rep. in 2007 to that in 2008?
Your response must be concise. 0.83. What is the ratio of the Expenses (in $) in Lithuania in 2007 to that in 2008?
Provide a short and direct response. 0.82. What is the ratio of the Expenses (in $) in Malta in 2007 to that in 2008?
Offer a terse response. 1.98. What is the ratio of the Expenses (in $) in Qatar in 2007 to that in 2008?
Offer a terse response. 0.86. What is the ratio of the Expenses (in $) of Egypt, Arab Rep. in 2007 to that in 2009?
Your response must be concise. 0.69. What is the ratio of the Expenses (in $) in Lithuania in 2007 to that in 2009?
Provide a succinct answer. 0.88. What is the ratio of the Expenses (in $) in Malta in 2007 to that in 2009?
Your response must be concise. 1.98. What is the ratio of the Expenses (in $) of Qatar in 2007 to that in 2009?
Your response must be concise. 0.75. What is the ratio of the Expenses (in $) in Egypt, Arab Rep. in 2007 to that in 2010?
Your response must be concise. 0.61. What is the ratio of the Expenses (in $) in Lithuania in 2007 to that in 2010?
Keep it short and to the point. 0.98. What is the ratio of the Expenses (in $) of Malta in 2007 to that in 2010?
Your answer should be very brief. 1.96. What is the ratio of the Expenses (in $) in Qatar in 2007 to that in 2010?
Keep it short and to the point. 0.7. What is the ratio of the Expenses (in $) of Egypt, Arab Rep. in 2008 to that in 2009?
Offer a terse response. 0.83. What is the ratio of the Expenses (in $) of Lithuania in 2008 to that in 2009?
Keep it short and to the point. 1.07. What is the ratio of the Expenses (in $) of Malta in 2008 to that in 2009?
Make the answer very short. 1. What is the ratio of the Expenses (in $) of Qatar in 2008 to that in 2009?
Keep it short and to the point. 0.87. What is the ratio of the Expenses (in $) of Egypt, Arab Rep. in 2008 to that in 2010?
Keep it short and to the point. 0.74. What is the ratio of the Expenses (in $) of Lithuania in 2008 to that in 2010?
Offer a terse response. 1.19. What is the ratio of the Expenses (in $) in Qatar in 2008 to that in 2010?
Your answer should be compact. 0.81. What is the ratio of the Expenses (in $) in Egypt, Arab Rep. in 2009 to that in 2010?
Offer a terse response. 0.89. What is the ratio of the Expenses (in $) of Lithuania in 2009 to that in 2010?
Your answer should be compact. 1.12. What is the ratio of the Expenses (in $) in Qatar in 2009 to that in 2010?
Your response must be concise. 0.93. What is the difference between the highest and the second highest Expenses (in $) of Egypt, Arab Rep.?
Make the answer very short. 9.41e+09. What is the difference between the highest and the second highest Expenses (in $) of Lithuania?
Provide a short and direct response. 3.80e+08. What is the difference between the highest and the second highest Expenses (in $) in Malta?
Your response must be concise. 7.19e+07. What is the difference between the highest and the second highest Expenses (in $) of Qatar?
Your answer should be compact. 1.67e+09. What is the difference between the highest and the lowest Expenses (in $) in Egypt, Arab Rep.?
Your answer should be compact. 4.87e+1. What is the difference between the highest and the lowest Expenses (in $) of Lithuania?
Make the answer very short. 2.93e+09. What is the difference between the highest and the lowest Expenses (in $) of Malta?
Your answer should be compact. 8.12e+08. What is the difference between the highest and the lowest Expenses (in $) in Qatar?
Give a very brief answer. 1.68e+1. 